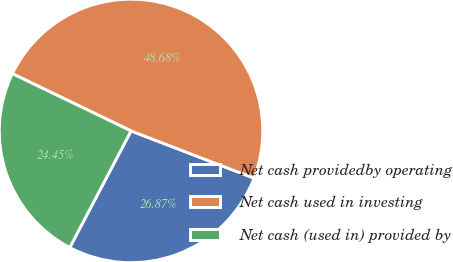<chart> <loc_0><loc_0><loc_500><loc_500><pie_chart><fcel>Net cash providedby operating<fcel>Net cash used in investing<fcel>Net cash (used in) provided by<nl><fcel>26.87%<fcel>48.68%<fcel>24.45%<nl></chart> 